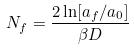Convert formula to latex. <formula><loc_0><loc_0><loc_500><loc_500>N _ { f } = \frac { 2 \ln [ a _ { f } / a _ { 0 } ] } { \beta D }</formula> 